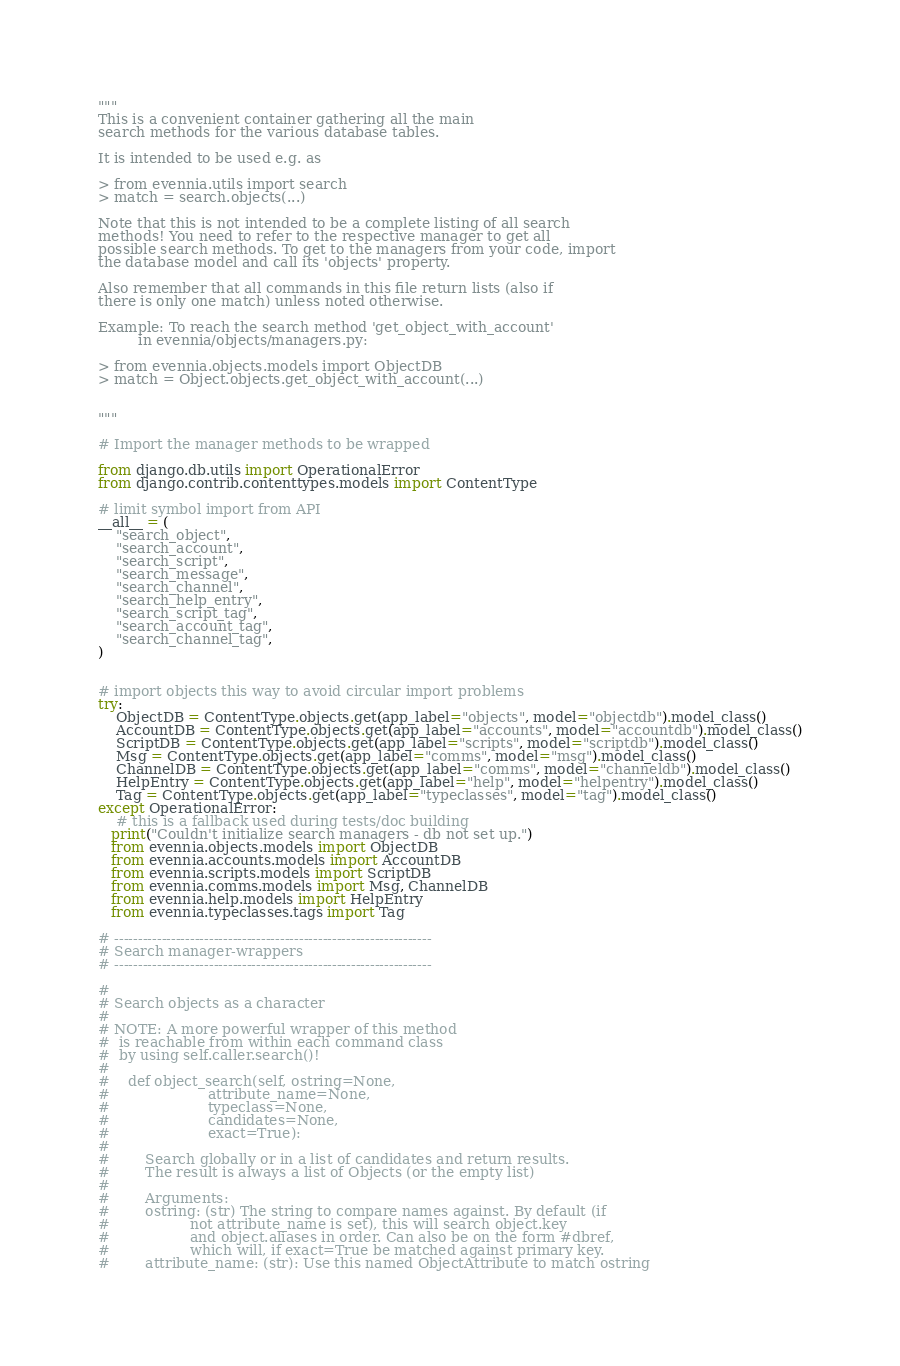<code> <loc_0><loc_0><loc_500><loc_500><_Python_>"""
This is a convenient container gathering all the main
search methods for the various database tables.

It is intended to be used e.g. as

> from evennia.utils import search
> match = search.objects(...)

Note that this is not intended to be a complete listing of all search
methods! You need to refer to the respective manager to get all
possible search methods. To get to the managers from your code, import
the database model and call its 'objects' property.

Also remember that all commands in this file return lists (also if
there is only one match) unless noted otherwise.

Example: To reach the search method 'get_object_with_account'
         in evennia/objects/managers.py:

> from evennia.objects.models import ObjectDB
> match = Object.objects.get_object_with_account(...)


"""

# Import the manager methods to be wrapped

from django.db.utils import OperationalError
from django.contrib.contenttypes.models import ContentType

# limit symbol import from API
__all__ = (
    "search_object",
    "search_account",
    "search_script",
    "search_message",
    "search_channel",
    "search_help_entry",
    "search_script_tag",
    "search_account_tag",
    "search_channel_tag",
)


# import objects this way to avoid circular import problems
try:
    ObjectDB = ContentType.objects.get(app_label="objects", model="objectdb").model_class()
    AccountDB = ContentType.objects.get(app_label="accounts", model="accountdb").model_class()
    ScriptDB = ContentType.objects.get(app_label="scripts", model="scriptdb").model_class()
    Msg = ContentType.objects.get(app_label="comms", model="msg").model_class()
    ChannelDB = ContentType.objects.get(app_label="comms", model="channeldb").model_class()
    HelpEntry = ContentType.objects.get(app_label="help", model="helpentry").model_class()
    Tag = ContentType.objects.get(app_label="typeclasses", model="tag").model_class()
except OperationalError:
    # this is a fallback used during tests/doc building
   print("Couldn't initialize search managers - db not set up.")
   from evennia.objects.models import ObjectDB
   from evennia.accounts.models import AccountDB
   from evennia.scripts.models import ScriptDB
   from evennia.comms.models import Msg, ChannelDB
   from evennia.help.models import HelpEntry
   from evennia.typeclasses.tags import Tag

# -------------------------------------------------------------------
# Search manager-wrappers
# -------------------------------------------------------------------

#
# Search objects as a character
#
# NOTE: A more powerful wrapper of this method
#  is reachable from within each command class
#  by using self.caller.search()!
#
#    def object_search(self, ostring=None,
#                      attribute_name=None,
#                      typeclass=None,
#                      candidates=None,
#                      exact=True):
#
#        Search globally or in a list of candidates and return results.
#        The result is always a list of Objects (or the empty list)
#
#        Arguments:
#        ostring: (str) The string to compare names against. By default (if
#                  not attribute_name is set), this will search object.key
#                  and object.aliases in order. Can also be on the form #dbref,
#                  which will, if exact=True be matched against primary key.
#        attribute_name: (str): Use this named ObjectAttribute to match ostring</code> 